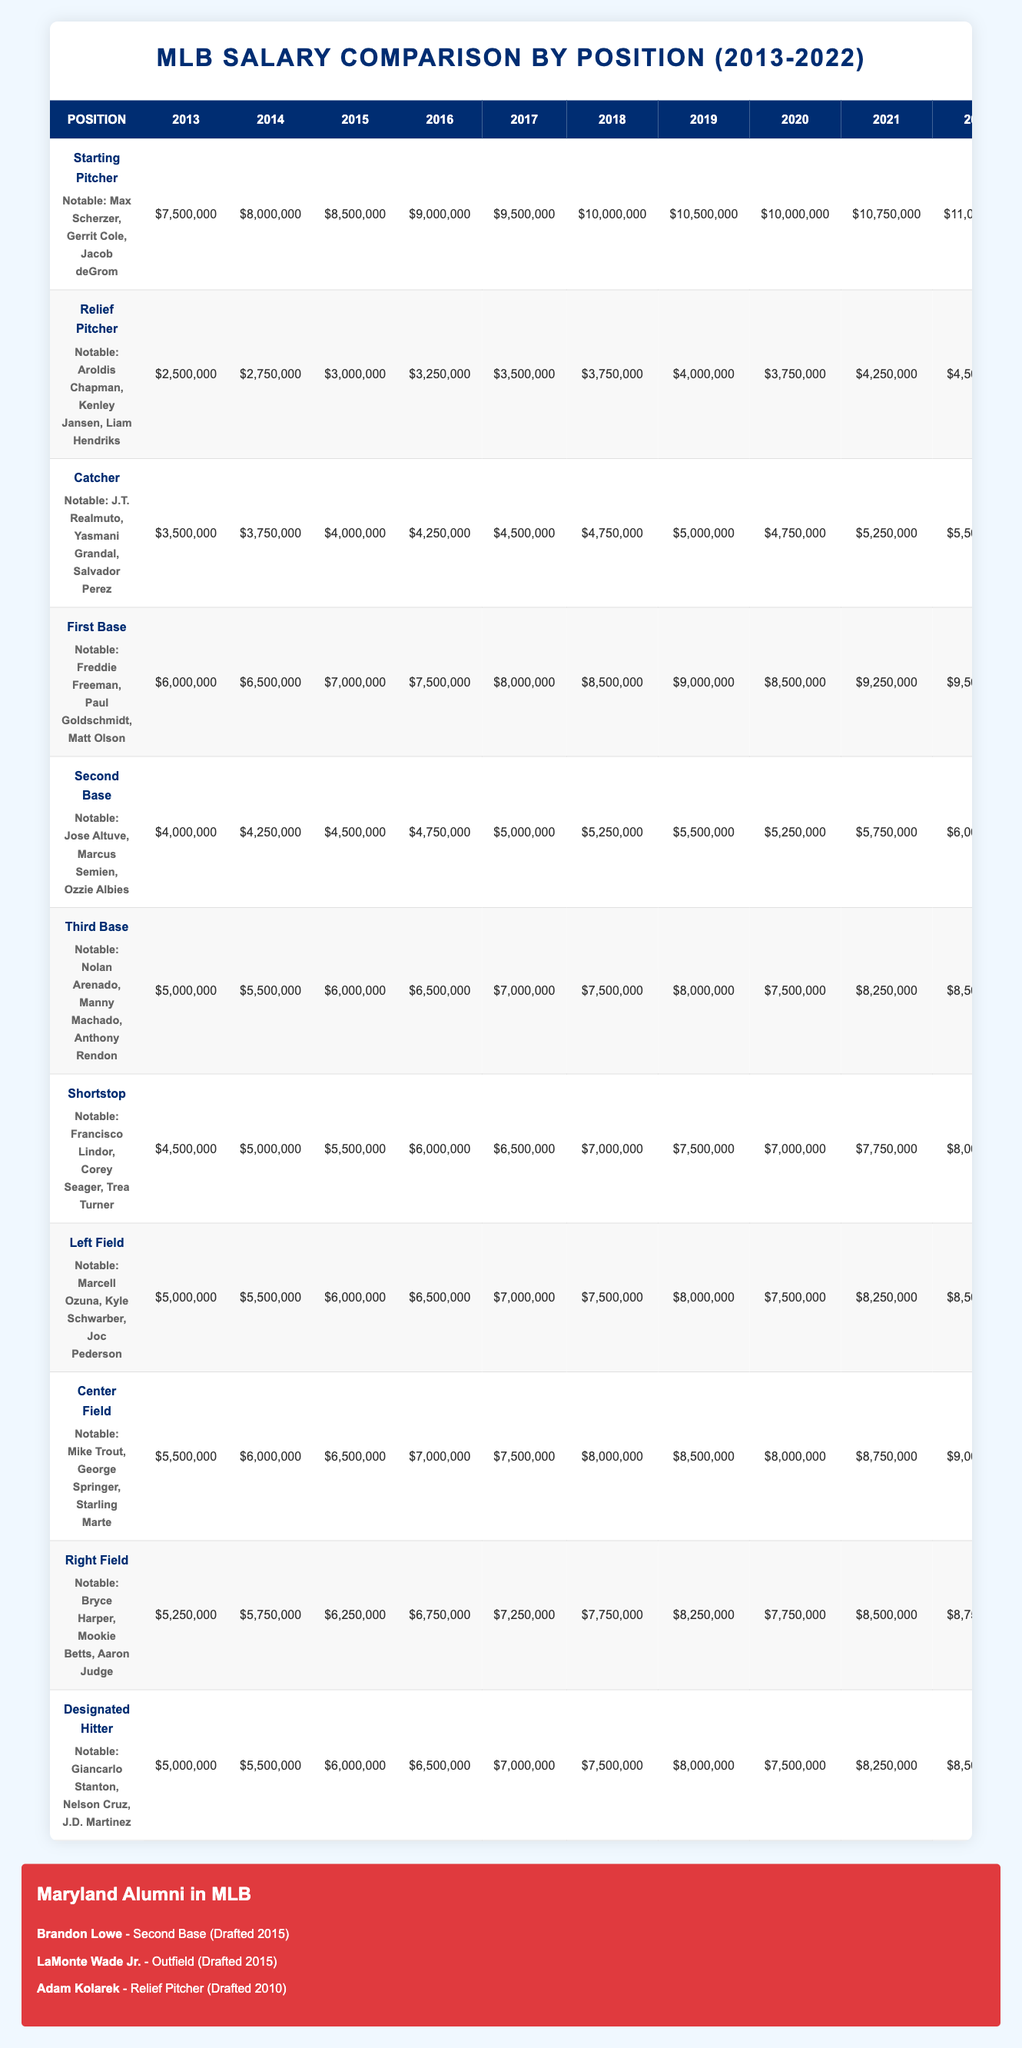What was the average salary for a starting pitcher in 2015? The average salary for a starting pitcher in 2015 is listed in the table under the 2015 column for that position, which is $8,500,000.
Answer: $8,500,000 Which position had the highest average salary in 2022? By comparing the average salaries listed in the 2022 column for each position, starting pitchers have the highest average salary at $11,000,000.
Answer: Starting Pitcher Did the average salary for relief pitchers increase every year from 2013 to 2022? Examining the annual salaries for relief pitchers from 2013 to 2022, we see that it increased in each year until 2020, where it dropped to $3,750,000, indicating it did not increase every year.
Answer: No How much higher was the average salary for shortstops in 2022 compared to 2013? The average salary for shortstops in 2022 is $8,000,000, and in 2013 it was $4,500,000. The difference is calculated as $8,000,000 - $4,500,000 = $3,500,000.
Answer: $3,500,000 Which position's average salary had the largest percentage increase over the decade (2013-2022)? To find the percentage increase for each position, we use the formula (final value - initial value) / initial value × 100. The maximum increase is for starting pitchers, which went from $7,500,000 in 2013 to $11,000,000 in 2022, resulting in an increase of 46.67%.
Answer: Starting Pitcher 